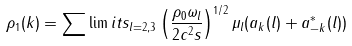Convert formula to latex. <formula><loc_0><loc_0><loc_500><loc_500>\rho _ { 1 } ( k ) = \sum \lim i t s _ { l = 2 , 3 } \left ( \frac { \rho _ { 0 } \omega _ { l } } { 2 c ^ { 2 } s } \right ) ^ { 1 / 2 } \mu _ { l } ( a _ { k } ( l ) + a ^ { * } _ { - k } ( l ) )</formula> 